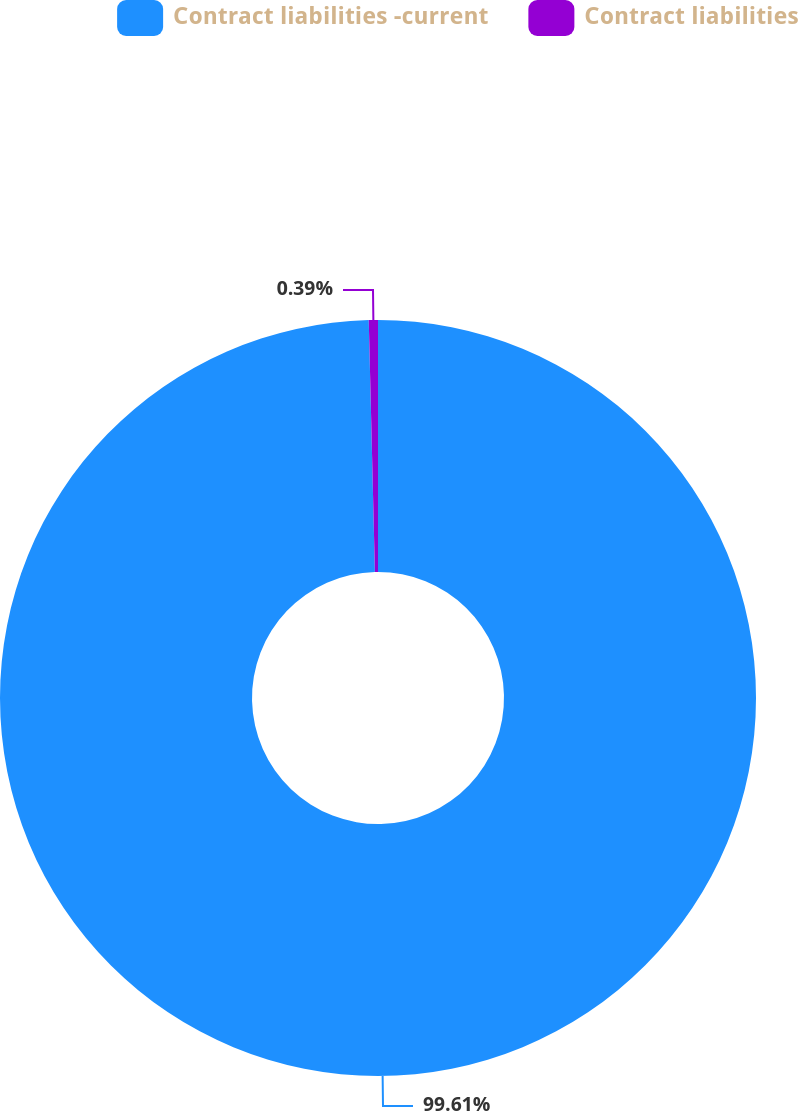Convert chart to OTSL. <chart><loc_0><loc_0><loc_500><loc_500><pie_chart><fcel>Contract liabilities -current<fcel>Contract liabilities<nl><fcel>99.61%<fcel>0.39%<nl></chart> 